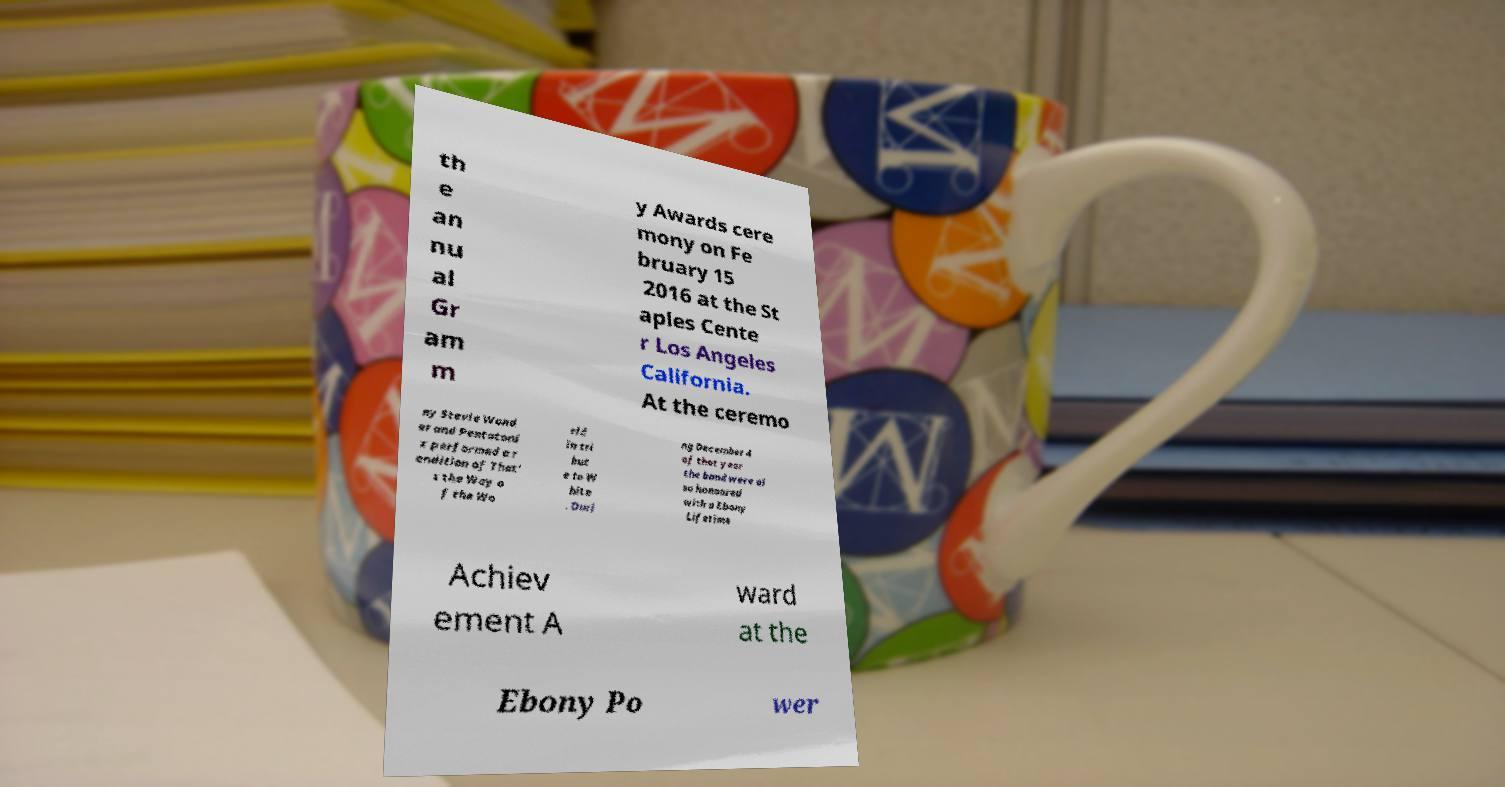There's text embedded in this image that I need extracted. Can you transcribe it verbatim? th e an nu al Gr am m y Awards cere mony on Fe bruary 15 2016 at the St aples Cente r Los Angeles California. At the ceremo ny Stevie Wond er and Pentatoni x performed a r endition of That' s the Way o f the Wo rld in tri but e to W hite . Duri ng December 4 of that year the band were al so honoured with a Ebony Lifetime Achiev ement A ward at the Ebony Po wer 